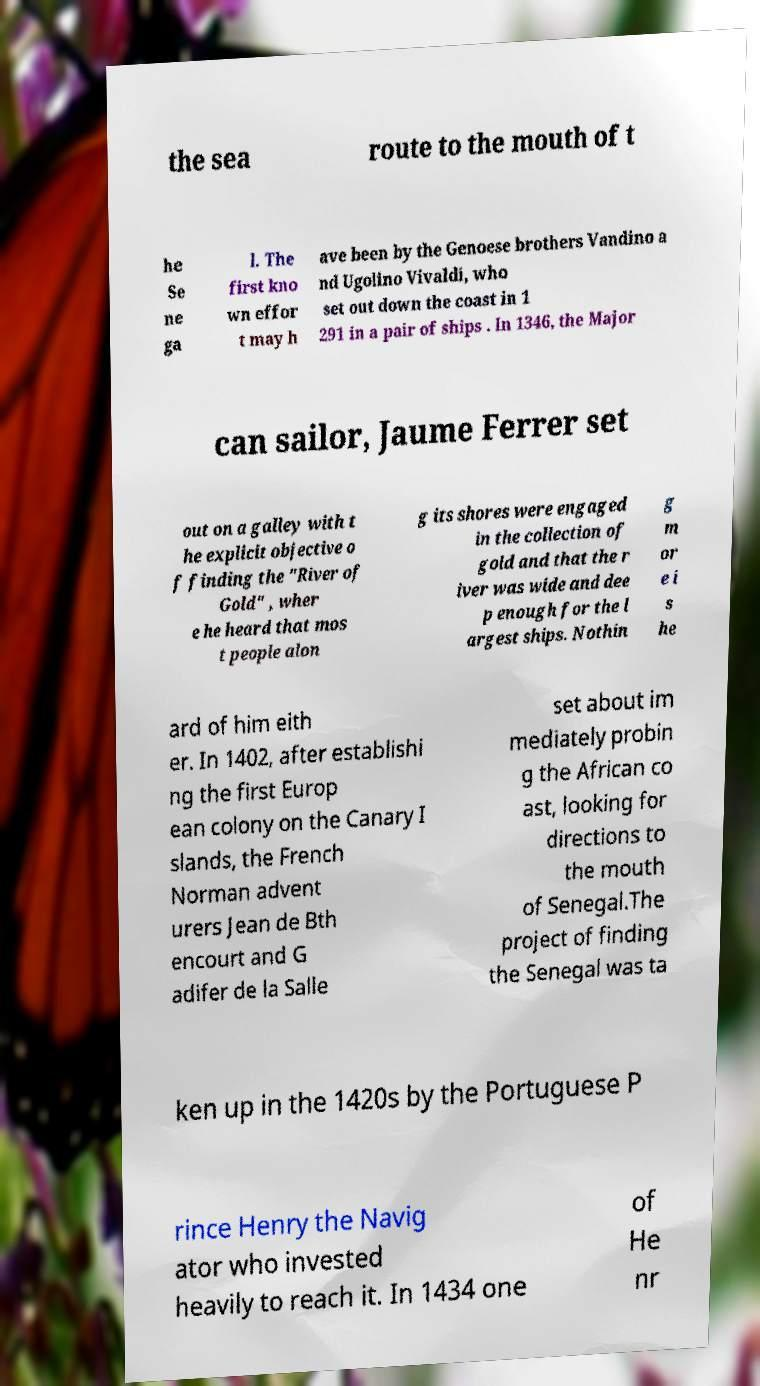Please identify and transcribe the text found in this image. the sea route to the mouth of t he Se ne ga l. The first kno wn effor t may h ave been by the Genoese brothers Vandino a nd Ugolino Vivaldi, who set out down the coast in 1 291 in a pair of ships . In 1346, the Major can sailor, Jaume Ferrer set out on a galley with t he explicit objective o f finding the "River of Gold" , wher e he heard that mos t people alon g its shores were engaged in the collection of gold and that the r iver was wide and dee p enough for the l argest ships. Nothin g m or e i s he ard of him eith er. In 1402, after establishi ng the first Europ ean colony on the Canary I slands, the French Norman advent urers Jean de Bth encourt and G adifer de la Salle set about im mediately probin g the African co ast, looking for directions to the mouth of Senegal.The project of finding the Senegal was ta ken up in the 1420s by the Portuguese P rince Henry the Navig ator who invested heavily to reach it. In 1434 one of He nr 